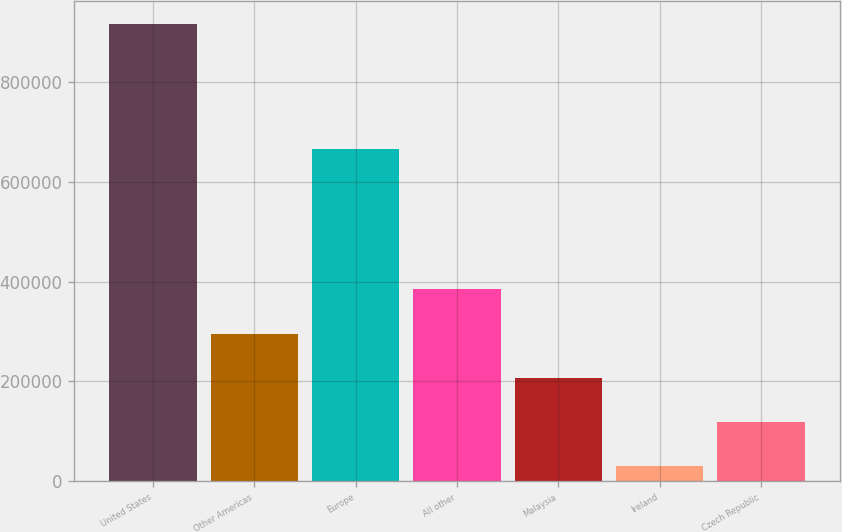Convert chart. <chart><loc_0><loc_0><loc_500><loc_500><bar_chart><fcel>United States<fcel>Other Americas<fcel>Europe<fcel>All other<fcel>Malaysia<fcel>Ireland<fcel>Czech Republic<nl><fcel>916619<fcel>295808<fcel>664982<fcel>384495<fcel>207121<fcel>29746<fcel>118433<nl></chart> 